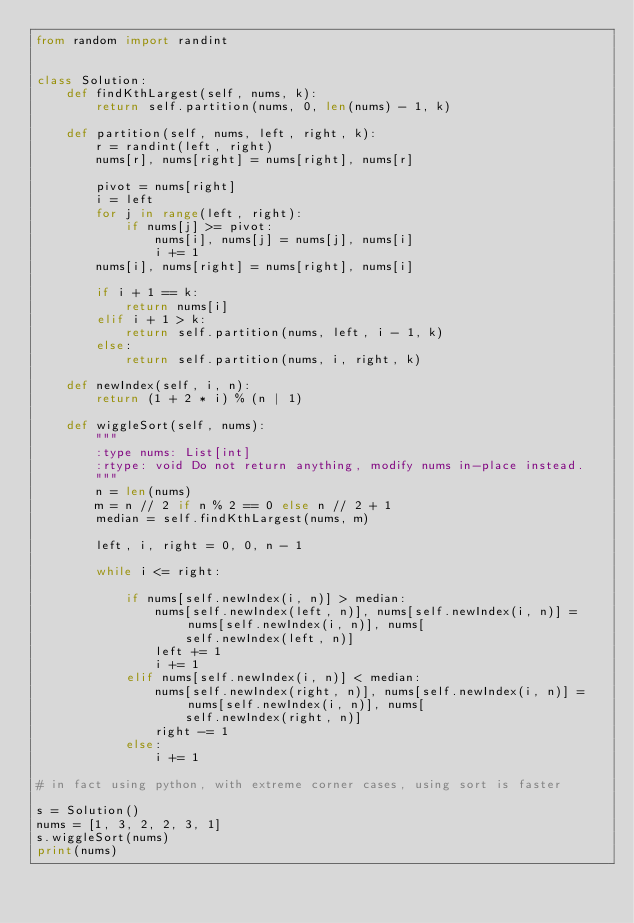<code> <loc_0><loc_0><loc_500><loc_500><_Python_>from random import randint


class Solution:
    def findKthLargest(self, nums, k):
        return self.partition(nums, 0, len(nums) - 1, k)

    def partition(self, nums, left, right, k):
        r = randint(left, right)
        nums[r], nums[right] = nums[right], nums[r]

        pivot = nums[right]
        i = left
        for j in range(left, right):
            if nums[j] >= pivot:
                nums[i], nums[j] = nums[j], nums[i]
                i += 1
        nums[i], nums[right] = nums[right], nums[i]

        if i + 1 == k:
            return nums[i]
        elif i + 1 > k:
            return self.partition(nums, left, i - 1, k)
        else:
            return self.partition(nums, i, right, k)

    def newIndex(self, i, n):
        return (1 + 2 * i) % (n | 1)

    def wiggleSort(self, nums):
        """
        :type nums: List[int]
        :rtype: void Do not return anything, modify nums in-place instead.
        """
        n = len(nums)
        m = n // 2 if n % 2 == 0 else n // 2 + 1
        median = self.findKthLargest(nums, m)

        left, i, right = 0, 0, n - 1

        while i <= right:

            if nums[self.newIndex(i, n)] > median:
                nums[self.newIndex(left, n)], nums[self.newIndex(i, n)] = nums[self.newIndex(i, n)], nums[
                    self.newIndex(left, n)]
                left += 1
                i += 1
            elif nums[self.newIndex(i, n)] < median:
                nums[self.newIndex(right, n)], nums[self.newIndex(i, n)] = nums[self.newIndex(i, n)], nums[
                    self.newIndex(right, n)]
                right -= 1
            else:
                i += 1

# in fact using python, with extreme corner cases, using sort is faster

s = Solution()
nums = [1, 3, 2, 2, 3, 1]
s.wiggleSort(nums)
print(nums)
</code> 